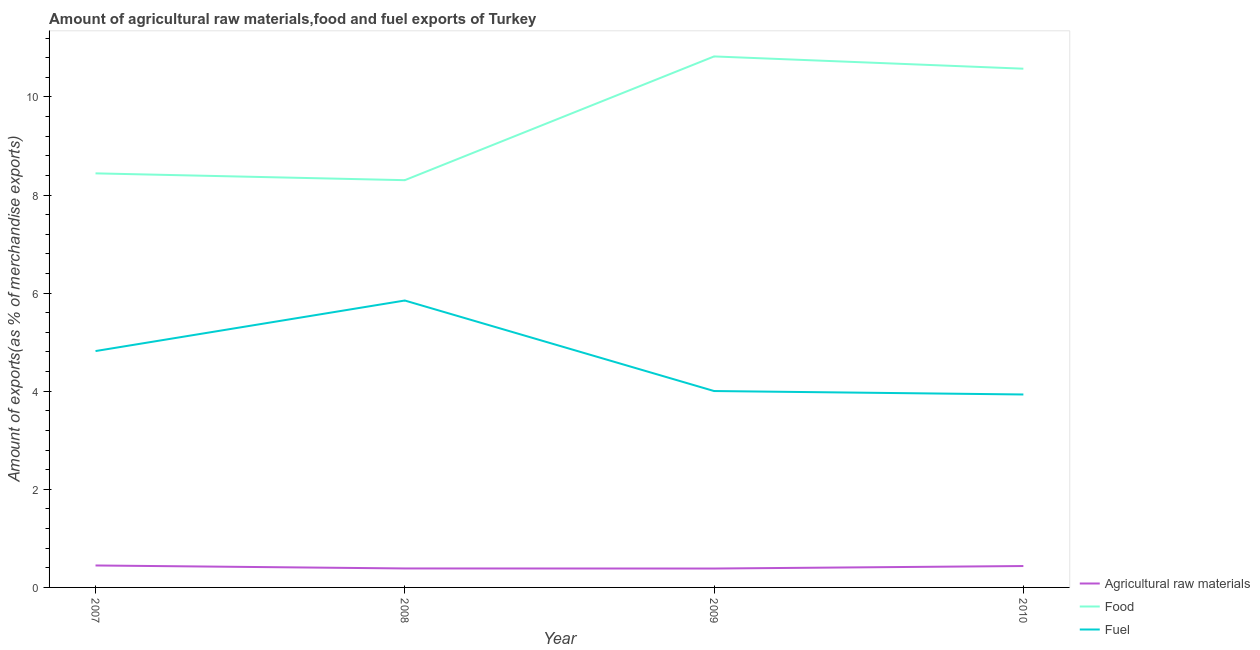How many different coloured lines are there?
Your answer should be compact. 3. Does the line corresponding to percentage of raw materials exports intersect with the line corresponding to percentage of food exports?
Make the answer very short. No. Is the number of lines equal to the number of legend labels?
Provide a succinct answer. Yes. What is the percentage of fuel exports in 2009?
Ensure brevity in your answer.  4. Across all years, what is the maximum percentage of fuel exports?
Give a very brief answer. 5.85. Across all years, what is the minimum percentage of fuel exports?
Provide a short and direct response. 3.93. What is the total percentage of raw materials exports in the graph?
Keep it short and to the point. 1.66. What is the difference between the percentage of raw materials exports in 2007 and that in 2009?
Provide a short and direct response. 0.06. What is the difference between the percentage of fuel exports in 2010 and the percentage of raw materials exports in 2007?
Give a very brief answer. 3.49. What is the average percentage of raw materials exports per year?
Keep it short and to the point. 0.41. In the year 2010, what is the difference between the percentage of raw materials exports and percentage of fuel exports?
Keep it short and to the point. -3.5. What is the ratio of the percentage of food exports in 2008 to that in 2010?
Provide a succinct answer. 0.79. What is the difference between the highest and the second highest percentage of fuel exports?
Give a very brief answer. 1.03. What is the difference between the highest and the lowest percentage of raw materials exports?
Offer a very short reply. 0.06. In how many years, is the percentage of raw materials exports greater than the average percentage of raw materials exports taken over all years?
Keep it short and to the point. 2. Is it the case that in every year, the sum of the percentage of raw materials exports and percentage of food exports is greater than the percentage of fuel exports?
Your answer should be very brief. Yes. How many lines are there?
Your answer should be compact. 3. How many years are there in the graph?
Your answer should be compact. 4. What is the difference between two consecutive major ticks on the Y-axis?
Offer a very short reply. 2. Are the values on the major ticks of Y-axis written in scientific E-notation?
Provide a succinct answer. No. Does the graph contain any zero values?
Offer a terse response. No. Where does the legend appear in the graph?
Ensure brevity in your answer.  Bottom right. How many legend labels are there?
Ensure brevity in your answer.  3. How are the legend labels stacked?
Your response must be concise. Vertical. What is the title of the graph?
Give a very brief answer. Amount of agricultural raw materials,food and fuel exports of Turkey. Does "Solid fuel" appear as one of the legend labels in the graph?
Make the answer very short. No. What is the label or title of the Y-axis?
Provide a succinct answer. Amount of exports(as % of merchandise exports). What is the Amount of exports(as % of merchandise exports) of Agricultural raw materials in 2007?
Your response must be concise. 0.45. What is the Amount of exports(as % of merchandise exports) of Food in 2007?
Offer a terse response. 8.44. What is the Amount of exports(as % of merchandise exports) in Fuel in 2007?
Your answer should be very brief. 4.82. What is the Amount of exports(as % of merchandise exports) of Agricultural raw materials in 2008?
Offer a terse response. 0.39. What is the Amount of exports(as % of merchandise exports) of Food in 2008?
Provide a short and direct response. 8.3. What is the Amount of exports(as % of merchandise exports) in Fuel in 2008?
Provide a succinct answer. 5.85. What is the Amount of exports(as % of merchandise exports) of Agricultural raw materials in 2009?
Your response must be concise. 0.39. What is the Amount of exports(as % of merchandise exports) of Food in 2009?
Keep it short and to the point. 10.83. What is the Amount of exports(as % of merchandise exports) of Fuel in 2009?
Keep it short and to the point. 4. What is the Amount of exports(as % of merchandise exports) of Agricultural raw materials in 2010?
Give a very brief answer. 0.44. What is the Amount of exports(as % of merchandise exports) in Food in 2010?
Provide a short and direct response. 10.58. What is the Amount of exports(as % of merchandise exports) of Fuel in 2010?
Your answer should be compact. 3.93. Across all years, what is the maximum Amount of exports(as % of merchandise exports) in Agricultural raw materials?
Your response must be concise. 0.45. Across all years, what is the maximum Amount of exports(as % of merchandise exports) of Food?
Your response must be concise. 10.83. Across all years, what is the maximum Amount of exports(as % of merchandise exports) of Fuel?
Offer a very short reply. 5.85. Across all years, what is the minimum Amount of exports(as % of merchandise exports) in Agricultural raw materials?
Your answer should be very brief. 0.39. Across all years, what is the minimum Amount of exports(as % of merchandise exports) of Food?
Give a very brief answer. 8.3. Across all years, what is the minimum Amount of exports(as % of merchandise exports) of Fuel?
Your answer should be compact. 3.93. What is the total Amount of exports(as % of merchandise exports) in Agricultural raw materials in the graph?
Keep it short and to the point. 1.66. What is the total Amount of exports(as % of merchandise exports) in Food in the graph?
Give a very brief answer. 38.15. What is the total Amount of exports(as % of merchandise exports) of Fuel in the graph?
Give a very brief answer. 18.61. What is the difference between the Amount of exports(as % of merchandise exports) of Agricultural raw materials in 2007 and that in 2008?
Ensure brevity in your answer.  0.06. What is the difference between the Amount of exports(as % of merchandise exports) of Food in 2007 and that in 2008?
Your answer should be very brief. 0.14. What is the difference between the Amount of exports(as % of merchandise exports) of Fuel in 2007 and that in 2008?
Provide a short and direct response. -1.03. What is the difference between the Amount of exports(as % of merchandise exports) in Agricultural raw materials in 2007 and that in 2009?
Provide a succinct answer. 0.06. What is the difference between the Amount of exports(as % of merchandise exports) of Food in 2007 and that in 2009?
Your response must be concise. -2.38. What is the difference between the Amount of exports(as % of merchandise exports) of Fuel in 2007 and that in 2009?
Your response must be concise. 0.81. What is the difference between the Amount of exports(as % of merchandise exports) of Agricultural raw materials in 2007 and that in 2010?
Your answer should be very brief. 0.01. What is the difference between the Amount of exports(as % of merchandise exports) of Food in 2007 and that in 2010?
Provide a short and direct response. -2.13. What is the difference between the Amount of exports(as % of merchandise exports) of Fuel in 2007 and that in 2010?
Provide a short and direct response. 0.89. What is the difference between the Amount of exports(as % of merchandise exports) in Agricultural raw materials in 2008 and that in 2009?
Your answer should be very brief. 0. What is the difference between the Amount of exports(as % of merchandise exports) of Food in 2008 and that in 2009?
Make the answer very short. -2.52. What is the difference between the Amount of exports(as % of merchandise exports) of Fuel in 2008 and that in 2009?
Provide a short and direct response. 1.85. What is the difference between the Amount of exports(as % of merchandise exports) of Agricultural raw materials in 2008 and that in 2010?
Ensure brevity in your answer.  -0.05. What is the difference between the Amount of exports(as % of merchandise exports) of Food in 2008 and that in 2010?
Provide a succinct answer. -2.27. What is the difference between the Amount of exports(as % of merchandise exports) in Fuel in 2008 and that in 2010?
Give a very brief answer. 1.92. What is the difference between the Amount of exports(as % of merchandise exports) of Agricultural raw materials in 2009 and that in 2010?
Your answer should be compact. -0.05. What is the difference between the Amount of exports(as % of merchandise exports) of Food in 2009 and that in 2010?
Offer a terse response. 0.25. What is the difference between the Amount of exports(as % of merchandise exports) in Fuel in 2009 and that in 2010?
Make the answer very short. 0.07. What is the difference between the Amount of exports(as % of merchandise exports) of Agricultural raw materials in 2007 and the Amount of exports(as % of merchandise exports) of Food in 2008?
Offer a very short reply. -7.86. What is the difference between the Amount of exports(as % of merchandise exports) in Agricultural raw materials in 2007 and the Amount of exports(as % of merchandise exports) in Fuel in 2008?
Your answer should be compact. -5.4. What is the difference between the Amount of exports(as % of merchandise exports) in Food in 2007 and the Amount of exports(as % of merchandise exports) in Fuel in 2008?
Give a very brief answer. 2.59. What is the difference between the Amount of exports(as % of merchandise exports) of Agricultural raw materials in 2007 and the Amount of exports(as % of merchandise exports) of Food in 2009?
Offer a very short reply. -10.38. What is the difference between the Amount of exports(as % of merchandise exports) of Agricultural raw materials in 2007 and the Amount of exports(as % of merchandise exports) of Fuel in 2009?
Give a very brief answer. -3.56. What is the difference between the Amount of exports(as % of merchandise exports) in Food in 2007 and the Amount of exports(as % of merchandise exports) in Fuel in 2009?
Offer a very short reply. 4.44. What is the difference between the Amount of exports(as % of merchandise exports) of Agricultural raw materials in 2007 and the Amount of exports(as % of merchandise exports) of Food in 2010?
Your answer should be compact. -10.13. What is the difference between the Amount of exports(as % of merchandise exports) of Agricultural raw materials in 2007 and the Amount of exports(as % of merchandise exports) of Fuel in 2010?
Your response must be concise. -3.49. What is the difference between the Amount of exports(as % of merchandise exports) of Food in 2007 and the Amount of exports(as % of merchandise exports) of Fuel in 2010?
Offer a terse response. 4.51. What is the difference between the Amount of exports(as % of merchandise exports) in Agricultural raw materials in 2008 and the Amount of exports(as % of merchandise exports) in Food in 2009?
Offer a terse response. -10.44. What is the difference between the Amount of exports(as % of merchandise exports) of Agricultural raw materials in 2008 and the Amount of exports(as % of merchandise exports) of Fuel in 2009?
Your answer should be very brief. -3.62. What is the difference between the Amount of exports(as % of merchandise exports) of Food in 2008 and the Amount of exports(as % of merchandise exports) of Fuel in 2009?
Ensure brevity in your answer.  4.3. What is the difference between the Amount of exports(as % of merchandise exports) of Agricultural raw materials in 2008 and the Amount of exports(as % of merchandise exports) of Food in 2010?
Ensure brevity in your answer.  -10.19. What is the difference between the Amount of exports(as % of merchandise exports) in Agricultural raw materials in 2008 and the Amount of exports(as % of merchandise exports) in Fuel in 2010?
Your answer should be very brief. -3.55. What is the difference between the Amount of exports(as % of merchandise exports) of Food in 2008 and the Amount of exports(as % of merchandise exports) of Fuel in 2010?
Make the answer very short. 4.37. What is the difference between the Amount of exports(as % of merchandise exports) of Agricultural raw materials in 2009 and the Amount of exports(as % of merchandise exports) of Food in 2010?
Offer a very short reply. -10.19. What is the difference between the Amount of exports(as % of merchandise exports) of Agricultural raw materials in 2009 and the Amount of exports(as % of merchandise exports) of Fuel in 2010?
Your answer should be very brief. -3.55. What is the difference between the Amount of exports(as % of merchandise exports) in Food in 2009 and the Amount of exports(as % of merchandise exports) in Fuel in 2010?
Offer a very short reply. 6.89. What is the average Amount of exports(as % of merchandise exports) of Agricultural raw materials per year?
Make the answer very short. 0.41. What is the average Amount of exports(as % of merchandise exports) of Food per year?
Offer a terse response. 9.54. What is the average Amount of exports(as % of merchandise exports) of Fuel per year?
Ensure brevity in your answer.  4.65. In the year 2007, what is the difference between the Amount of exports(as % of merchandise exports) in Agricultural raw materials and Amount of exports(as % of merchandise exports) in Food?
Ensure brevity in your answer.  -7.99. In the year 2007, what is the difference between the Amount of exports(as % of merchandise exports) of Agricultural raw materials and Amount of exports(as % of merchandise exports) of Fuel?
Ensure brevity in your answer.  -4.37. In the year 2007, what is the difference between the Amount of exports(as % of merchandise exports) of Food and Amount of exports(as % of merchandise exports) of Fuel?
Keep it short and to the point. 3.62. In the year 2008, what is the difference between the Amount of exports(as % of merchandise exports) of Agricultural raw materials and Amount of exports(as % of merchandise exports) of Food?
Your response must be concise. -7.92. In the year 2008, what is the difference between the Amount of exports(as % of merchandise exports) of Agricultural raw materials and Amount of exports(as % of merchandise exports) of Fuel?
Your answer should be compact. -5.46. In the year 2008, what is the difference between the Amount of exports(as % of merchandise exports) in Food and Amount of exports(as % of merchandise exports) in Fuel?
Give a very brief answer. 2.45. In the year 2009, what is the difference between the Amount of exports(as % of merchandise exports) in Agricultural raw materials and Amount of exports(as % of merchandise exports) in Food?
Provide a succinct answer. -10.44. In the year 2009, what is the difference between the Amount of exports(as % of merchandise exports) of Agricultural raw materials and Amount of exports(as % of merchandise exports) of Fuel?
Give a very brief answer. -3.62. In the year 2009, what is the difference between the Amount of exports(as % of merchandise exports) of Food and Amount of exports(as % of merchandise exports) of Fuel?
Provide a succinct answer. 6.82. In the year 2010, what is the difference between the Amount of exports(as % of merchandise exports) in Agricultural raw materials and Amount of exports(as % of merchandise exports) in Food?
Offer a terse response. -10.14. In the year 2010, what is the difference between the Amount of exports(as % of merchandise exports) of Agricultural raw materials and Amount of exports(as % of merchandise exports) of Fuel?
Your answer should be very brief. -3.5. In the year 2010, what is the difference between the Amount of exports(as % of merchandise exports) of Food and Amount of exports(as % of merchandise exports) of Fuel?
Your response must be concise. 6.64. What is the ratio of the Amount of exports(as % of merchandise exports) of Agricultural raw materials in 2007 to that in 2008?
Keep it short and to the point. 1.16. What is the ratio of the Amount of exports(as % of merchandise exports) of Food in 2007 to that in 2008?
Provide a short and direct response. 1.02. What is the ratio of the Amount of exports(as % of merchandise exports) in Fuel in 2007 to that in 2008?
Your answer should be compact. 0.82. What is the ratio of the Amount of exports(as % of merchandise exports) in Agricultural raw materials in 2007 to that in 2009?
Ensure brevity in your answer.  1.16. What is the ratio of the Amount of exports(as % of merchandise exports) in Food in 2007 to that in 2009?
Make the answer very short. 0.78. What is the ratio of the Amount of exports(as % of merchandise exports) in Fuel in 2007 to that in 2009?
Give a very brief answer. 1.2. What is the ratio of the Amount of exports(as % of merchandise exports) in Agricultural raw materials in 2007 to that in 2010?
Your answer should be very brief. 1.03. What is the ratio of the Amount of exports(as % of merchandise exports) in Food in 2007 to that in 2010?
Offer a terse response. 0.8. What is the ratio of the Amount of exports(as % of merchandise exports) of Fuel in 2007 to that in 2010?
Provide a short and direct response. 1.23. What is the ratio of the Amount of exports(as % of merchandise exports) in Agricultural raw materials in 2008 to that in 2009?
Offer a very short reply. 1. What is the ratio of the Amount of exports(as % of merchandise exports) in Food in 2008 to that in 2009?
Offer a very short reply. 0.77. What is the ratio of the Amount of exports(as % of merchandise exports) in Fuel in 2008 to that in 2009?
Offer a terse response. 1.46. What is the ratio of the Amount of exports(as % of merchandise exports) of Agricultural raw materials in 2008 to that in 2010?
Offer a terse response. 0.89. What is the ratio of the Amount of exports(as % of merchandise exports) in Food in 2008 to that in 2010?
Provide a short and direct response. 0.79. What is the ratio of the Amount of exports(as % of merchandise exports) of Fuel in 2008 to that in 2010?
Your response must be concise. 1.49. What is the ratio of the Amount of exports(as % of merchandise exports) in Agricultural raw materials in 2009 to that in 2010?
Offer a terse response. 0.88. What is the ratio of the Amount of exports(as % of merchandise exports) of Food in 2009 to that in 2010?
Give a very brief answer. 1.02. What is the ratio of the Amount of exports(as % of merchandise exports) of Fuel in 2009 to that in 2010?
Provide a succinct answer. 1.02. What is the difference between the highest and the second highest Amount of exports(as % of merchandise exports) in Agricultural raw materials?
Your answer should be very brief. 0.01. What is the difference between the highest and the second highest Amount of exports(as % of merchandise exports) of Food?
Provide a succinct answer. 0.25. What is the difference between the highest and the second highest Amount of exports(as % of merchandise exports) of Fuel?
Give a very brief answer. 1.03. What is the difference between the highest and the lowest Amount of exports(as % of merchandise exports) in Agricultural raw materials?
Provide a short and direct response. 0.06. What is the difference between the highest and the lowest Amount of exports(as % of merchandise exports) in Food?
Give a very brief answer. 2.52. What is the difference between the highest and the lowest Amount of exports(as % of merchandise exports) in Fuel?
Provide a short and direct response. 1.92. 